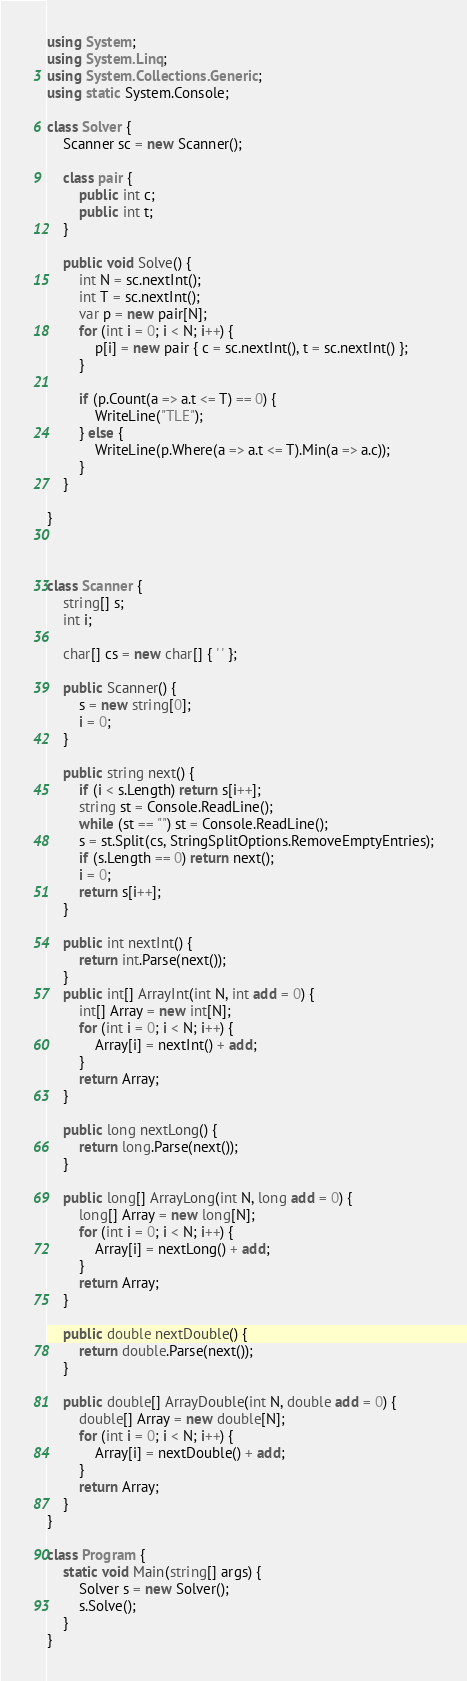<code> <loc_0><loc_0><loc_500><loc_500><_C#_>using System;
using System.Linq;
using System.Collections.Generic;
using static System.Console;

class Solver {
    Scanner sc = new Scanner();

    class pair {
        public int c;
        public int t;
    }

    public void Solve() {
        int N = sc.nextInt();
        int T = sc.nextInt();
        var p = new pair[N];
        for (int i = 0; i < N; i++) {
            p[i] = new pair { c = sc.nextInt(), t = sc.nextInt() };
        }

        if (p.Count(a => a.t <= T) == 0) {
            WriteLine("TLE");
        } else {
            WriteLine(p.Where(a => a.t <= T).Min(a => a.c));
        }
    }

}



class Scanner {
    string[] s;
    int i;

    char[] cs = new char[] { ' ' };

    public Scanner() {
        s = new string[0];
        i = 0;
    }

    public string next() {
        if (i < s.Length) return s[i++];
        string st = Console.ReadLine();
        while (st == "") st = Console.ReadLine();
        s = st.Split(cs, StringSplitOptions.RemoveEmptyEntries);
        if (s.Length == 0) return next();
        i = 0;
        return s[i++];
    }

    public int nextInt() {
        return int.Parse(next());
    }
    public int[] ArrayInt(int N, int add = 0) {
        int[] Array = new int[N];
        for (int i = 0; i < N; i++) {
            Array[i] = nextInt() + add;
        }
        return Array;
    }

    public long nextLong() {
        return long.Parse(next());
    }

    public long[] ArrayLong(int N, long add = 0) {
        long[] Array = new long[N];
        for (int i = 0; i < N; i++) {
            Array[i] = nextLong() + add;
        }
        return Array;
    }

    public double nextDouble() {
        return double.Parse(next());
    }

    public double[] ArrayDouble(int N, double add = 0) {
        double[] Array = new double[N];
        for (int i = 0; i < N; i++) {
            Array[i] = nextDouble() + add;
        }
        return Array;
    }
}

class Program {
    static void Main(string[] args) {
        Solver s = new Solver();
        s.Solve();
    }
}
</code> 